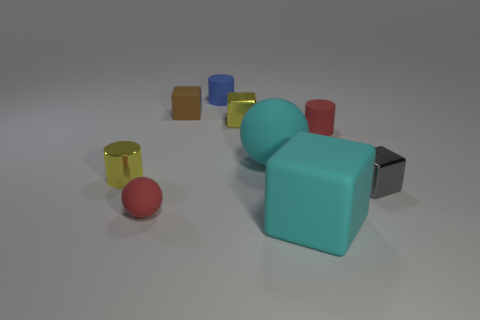Subtract all balls. How many objects are left? 7 Subtract all big blocks. Subtract all cyan rubber balls. How many objects are left? 7 Add 6 brown objects. How many brown objects are left? 7 Add 6 large rubber blocks. How many large rubber blocks exist? 7 Subtract 1 gray cubes. How many objects are left? 8 